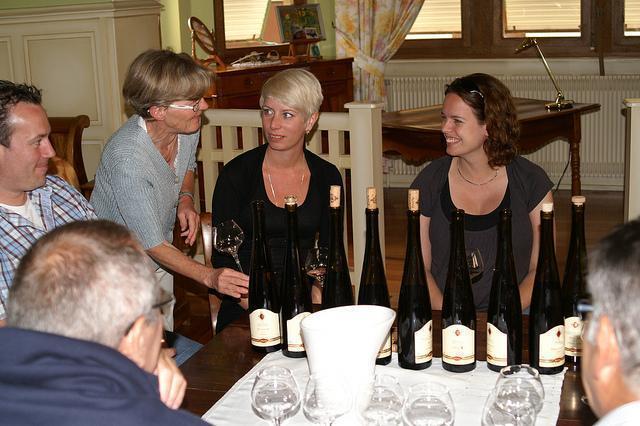What is in the bottle all the way to the right that is near the brunette woman?
Answer the question by selecting the correct answer among the 4 following choices.
Options: Cheese, cork, milk, orange juice. Cork. 